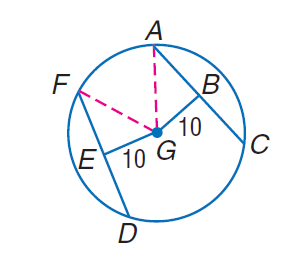Question: Chords A C and D F are equidistant from the center. If the radius of \odot G is 26, find D E.
Choices:
A. 12
B. 20
C. 24
D. 26
Answer with the letter. Answer: C 